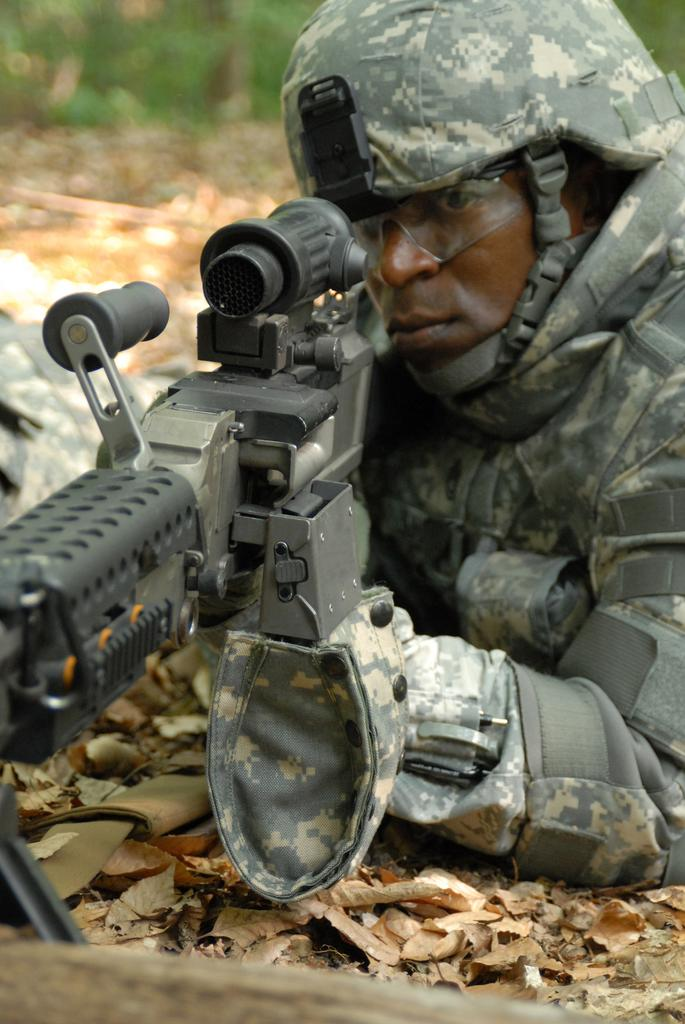What is present in the foreground of the picture? There are dry leaves and a soldier in the foreground of the picture. What is the soldier holding in the image? The soldier is holding a gun. What can be seen in the background of the image? The background of the image is blurred. What type of object is at the bottom of the image? There is a wooden object at the bottom of the image. How many apples are being minded by the soldier in the image? There are no apples present in the image, and the soldier is not shown minding any objects. What is the limit of the soldier's abilities in the image? The image does not provide information about the soldier's abilities or limitations. 